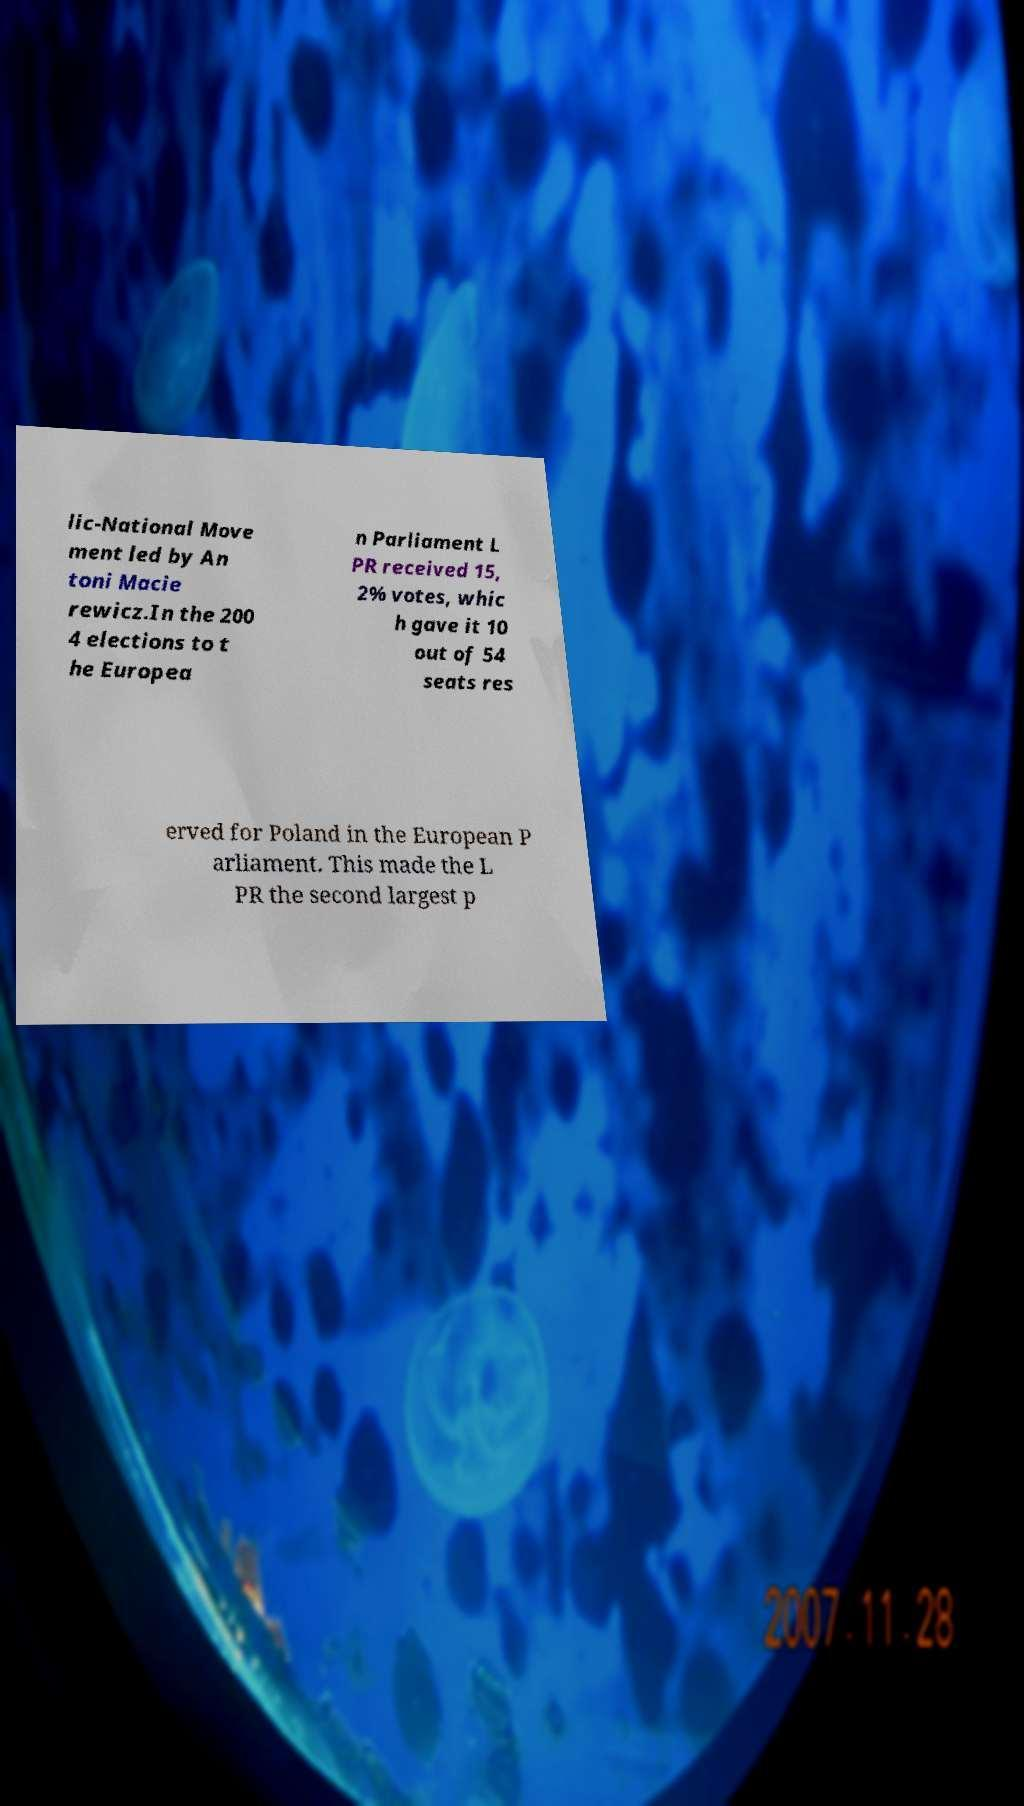For documentation purposes, I need the text within this image transcribed. Could you provide that? lic-National Move ment led by An toni Macie rewicz.In the 200 4 elections to t he Europea n Parliament L PR received 15, 2% votes, whic h gave it 10 out of 54 seats res erved for Poland in the European P arliament. This made the L PR the second largest p 